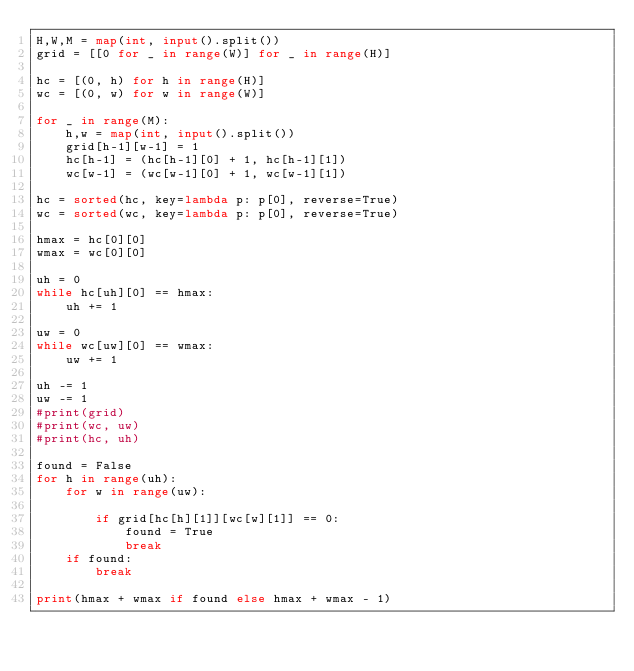<code> <loc_0><loc_0><loc_500><loc_500><_Python_>H,W,M = map(int, input().split())
grid = [[0 for _ in range(W)] for _ in range(H)]

hc = [(0, h) for h in range(H)]
wc = [(0, w) for w in range(W)]

for _ in range(M):
    h,w = map(int, input().split())
    grid[h-1][w-1] = 1
    hc[h-1] = (hc[h-1][0] + 1, hc[h-1][1])
    wc[w-1] = (wc[w-1][0] + 1, wc[w-1][1])

hc = sorted(hc, key=lambda p: p[0], reverse=True)
wc = sorted(wc, key=lambda p: p[0], reverse=True)

hmax = hc[0][0]
wmax = wc[0][0]

uh = 0
while hc[uh][0] == hmax:
    uh += 1

uw = 0
while wc[uw][0] == wmax:
    uw += 1

uh -= 1
uw -= 1
#print(grid)
#print(wc, uw)
#print(hc, uh)

found = False
for h in range(uh):
    for w in range(uw):

        if grid[hc[h][1]][wc[w][1]] == 0:
            found = True
            break
    if found:
        break

print(hmax + wmax if found else hmax + wmax - 1)</code> 